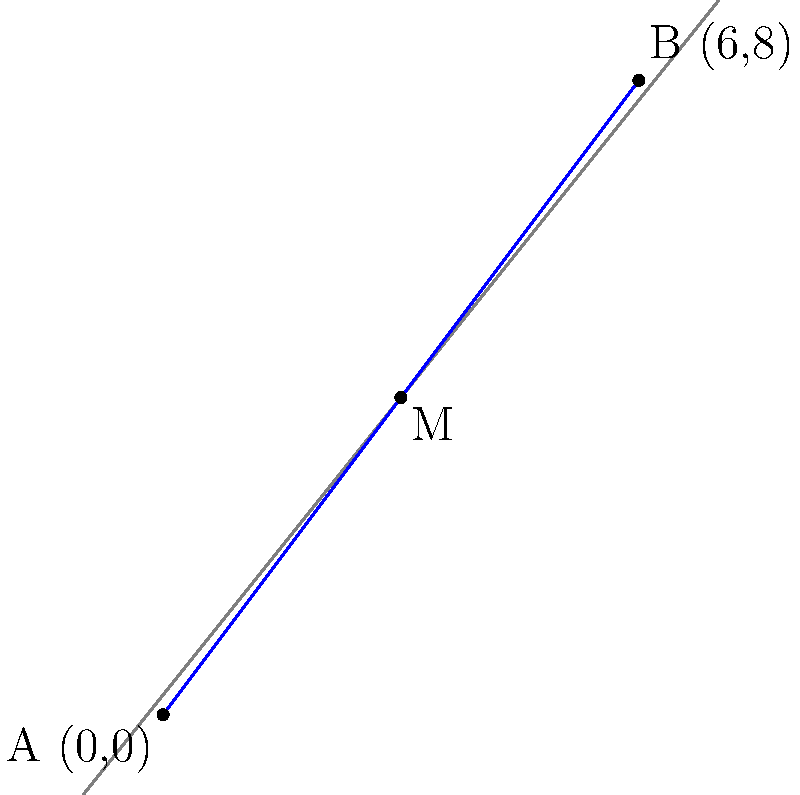During a creek hiking adventure in Nebraska, you discover two landmarks: a unique rock formation (A) and a scenic waterfall (B). On your trail map, these points are represented as A(0,0) and B(6,8) respectively. You want to establish a midpoint camp (M) along the trail connecting these two landmarks. What are the coordinates of the midpoint M? To find the midpoint M of the line segment connecting points A(0,0) and B(6,8), we can use the midpoint formula:

$$ M = (\frac{x_1 + x_2}{2}, \frac{y_1 + y_2}{2}) $$

Where $(x_1, y_1)$ are the coordinates of point A, and $(x_2, y_2)$ are the coordinates of point B.

Step 1: Identify the coordinates
A: $(x_1, y_1) = (0, 0)$
B: $(x_2, y_2) = (6, 8)$

Step 2: Calculate the x-coordinate of the midpoint
$x_M = \frac{x_1 + x_2}{2} = \frac{0 + 6}{2} = \frac{6}{2} = 3$

Step 3: Calculate the y-coordinate of the midpoint
$y_M = \frac{y_1 + y_2}{2} = \frac{0 + 8}{2} = \frac{8}{2} = 4$

Therefore, the coordinates of the midpoint M are (3, 4).
Answer: (3, 4) 